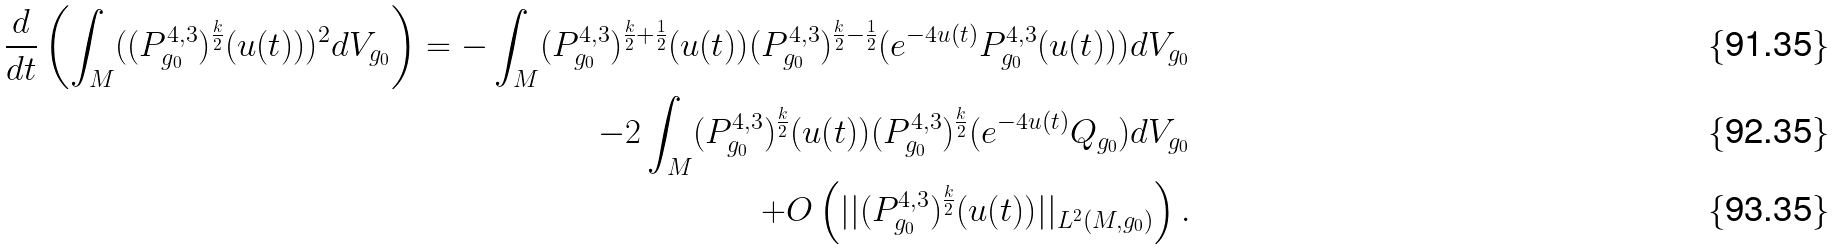<formula> <loc_0><loc_0><loc_500><loc_500>\frac { d } { d t } \left ( \int _ { M } ( ( P ^ { 4 , 3 } _ { g _ { 0 } } ) ^ { \frac { k } { 2 } } ( u ( t ) ) ) ^ { 2 } d V _ { g _ { 0 } } \right ) = - \int _ { M } ( P ^ { 4 , 3 } _ { g _ { 0 } } ) ^ { \frac { k } { 2 } + \frac { 1 } { 2 } } ( u ( t ) ) ( P ^ { 4 , 3 } _ { g _ { 0 } } ) ^ { \frac { k } { 2 } - \frac { 1 } { 2 } } ( e ^ { - 4 u ( t ) } P ^ { 4 , 3 } _ { g _ { 0 } } ( u ( t ) ) ) d V _ { g _ { 0 } } \\ - 2 \int _ { M } ( P ^ { 4 , 3 } _ { g _ { 0 } } ) ^ { \frac { k } { 2 } } ( u ( t ) ) ( P ^ { 4 , 3 } _ { g _ { 0 } } ) ^ { \frac { k } { 2 } } ( e ^ { - 4 u ( t ) } Q _ { g _ { 0 } } ) d V _ { g _ { 0 } } \\ + O \left ( | | ( P ^ { 4 , 3 } _ { g _ { 0 } } ) ^ { \frac { k } { 2 } } ( u ( t ) ) | | _ { L ^ { 2 } ( M , g _ { 0 } ) } \right ) .</formula> 